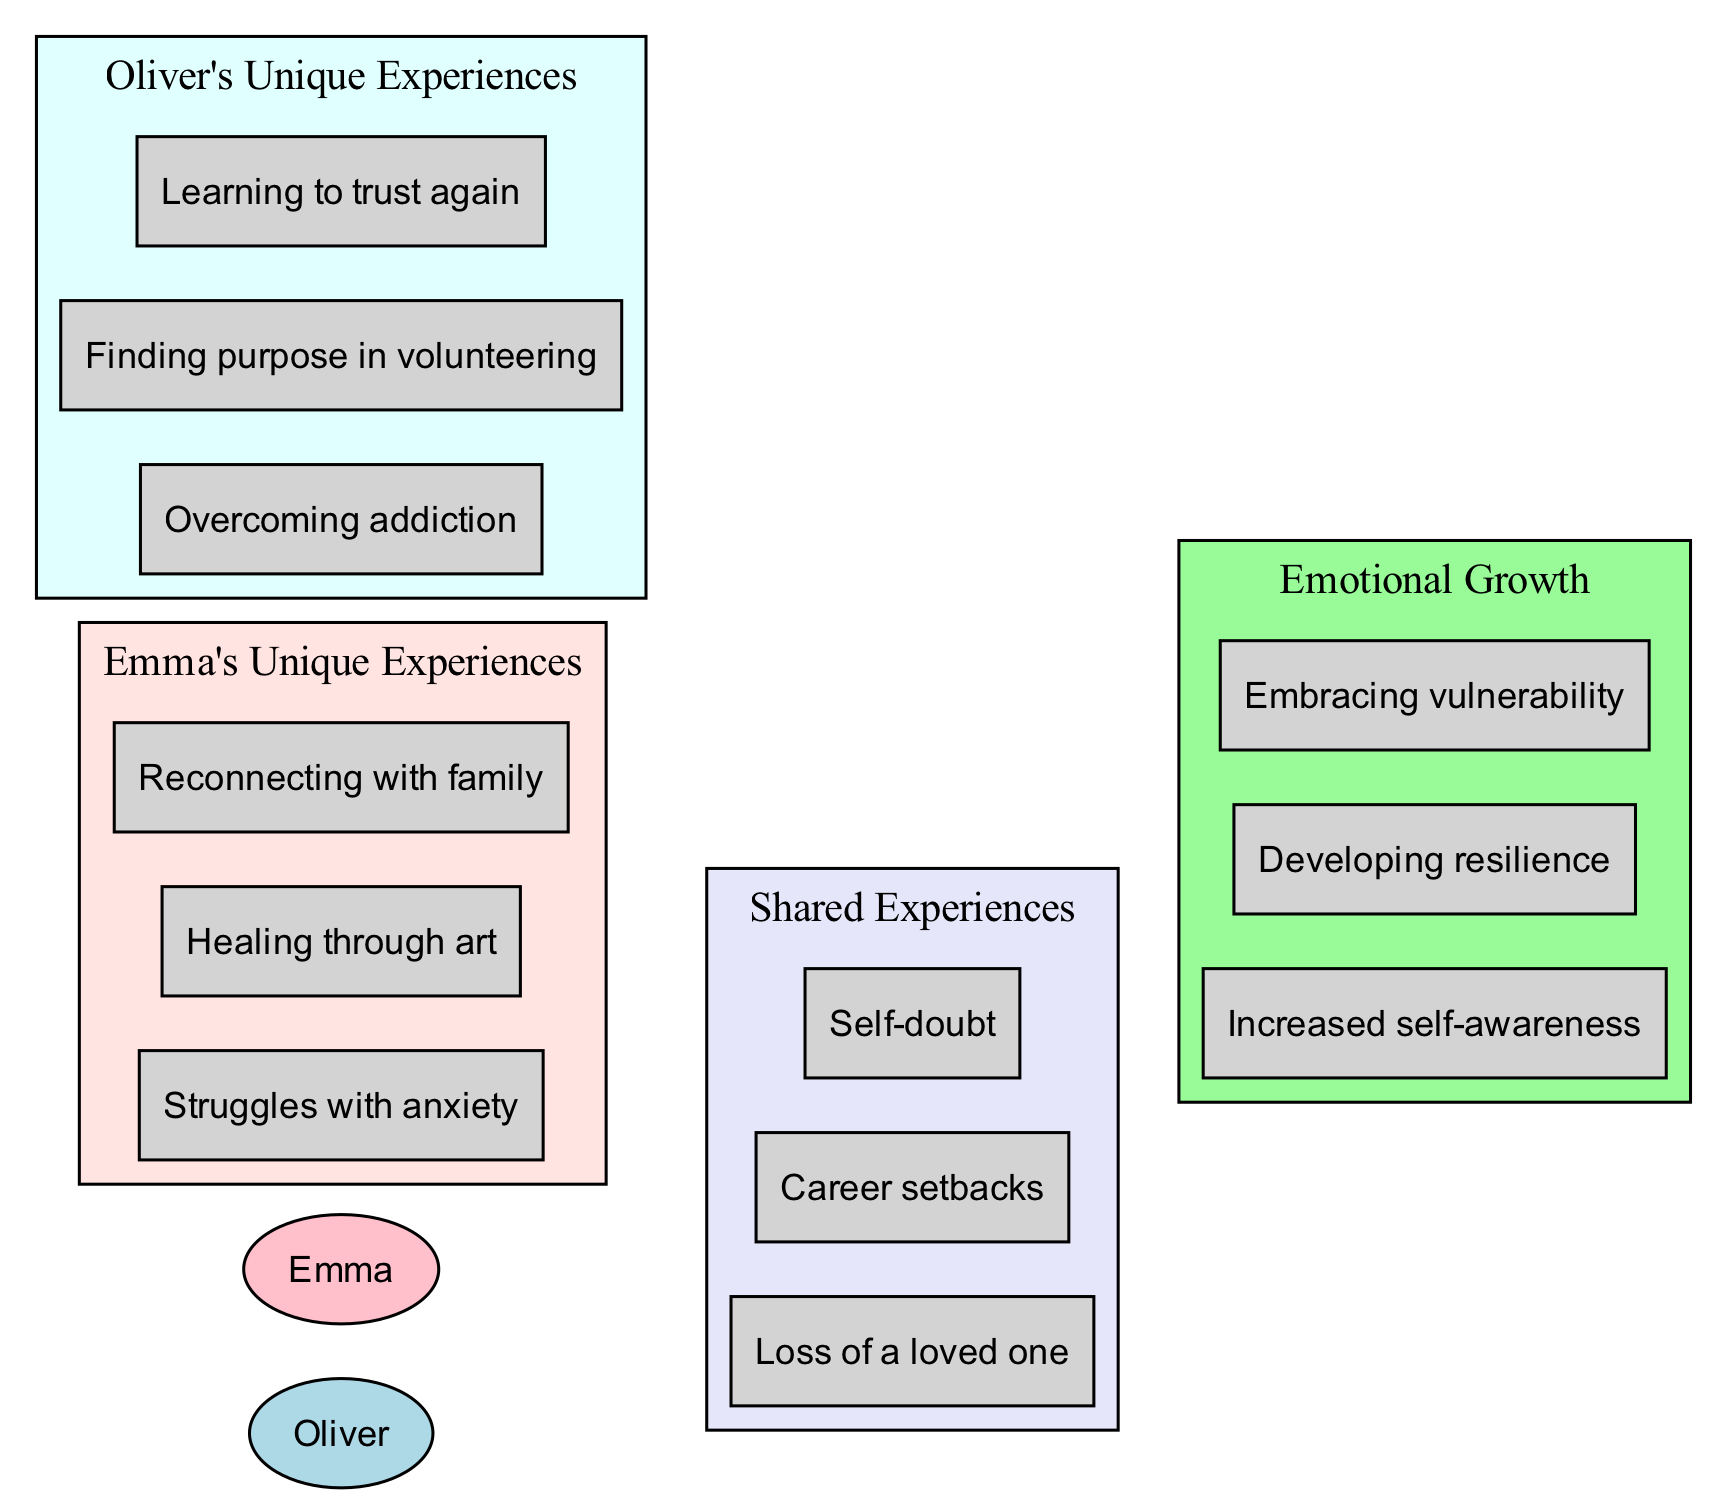What shared experience do both characters have? The shared experiences node indicates "Loss of a loved one," which is listed as something both Emma and Oliver have endured.
Answer: Loss of a loved one How many unique experiences does Emma have? By checking the number of nodes under "Emma's Unique Experiences," we find there are three unique experiences listed for her.
Answer: 3 What is Oliver's unique experience related to trust? From Oliver's unique experiences, "Learning to trust again" is specifically related to his journey with trust issues.
Answer: Learning to trust again Name one aspect of emotional growth common to both characters. The diagram shows several aspects of emotional growth, and "Increased self-awareness" appears in the emotional growth section, indicating it is a shared growth attribute.
Answer: Increased self-awareness Which character deals with addiction? "Overcoming addiction" is listed under Oliver's unique experiences; thus, it specifically indicates his battle related to this issue.
Answer: Oliver What is one of Emma's healing methods? Under Emma's unique experiences, "Healing through art" is highlighted as her method of coping and healing through her emotional journey.
Answer: Healing through art How many shared experiences are depicted in the diagram? Upon reviewing the shared experiences cluster, we find a total of three different shared experiences are indicated.
Answer: 3 What does the diagram suggest Emma and Oliver both experience? They both go through "Self-doubt," which is listed as part of their shared experiences, indicating that they relate to that emotional challenge together.
Answer: Self-doubt What unique experience highlights Oliver's commitment to helping others? "Finding purpose in volunteering" is distinctly listed under Oliver's unique experiences, showcasing his dedication to supporting the community.
Answer: Finding purpose in volunteering 